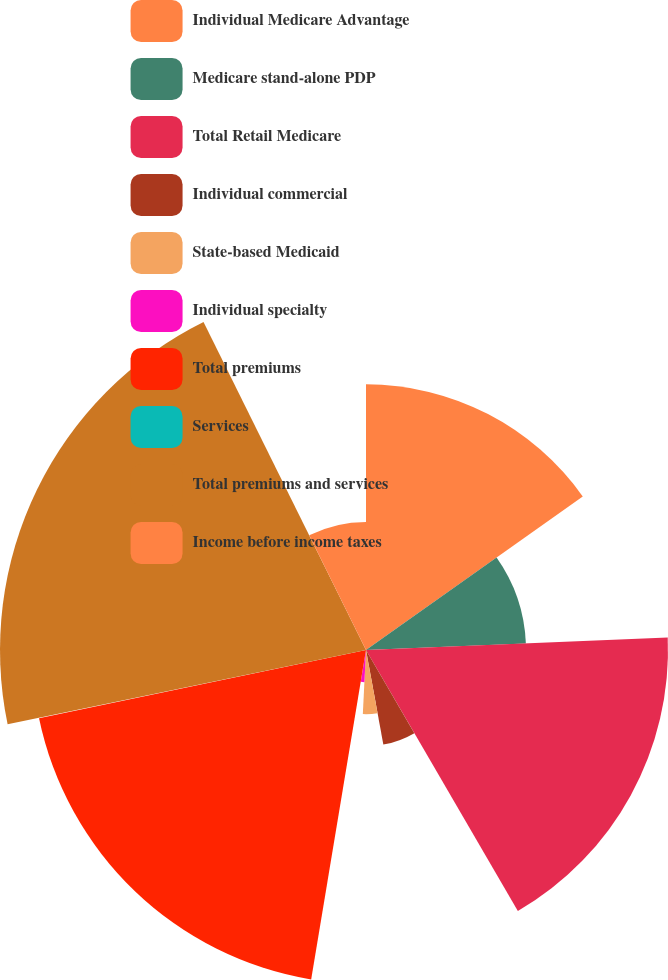Convert chart. <chart><loc_0><loc_0><loc_500><loc_500><pie_chart><fcel>Individual Medicare Advantage<fcel>Medicare stand-alone PDP<fcel>Total Retail Medicare<fcel>Individual commercial<fcel>State-based Medicaid<fcel>Individual specialty<fcel>Total premiums<fcel>Services<fcel>Total premiums and services<fcel>Income before income taxes<nl><fcel>15.19%<fcel>9.15%<fcel>17.27%<fcel>5.5%<fcel>3.67%<fcel>1.84%<fcel>19.1%<fcel>0.02%<fcel>20.93%<fcel>7.32%<nl></chart> 